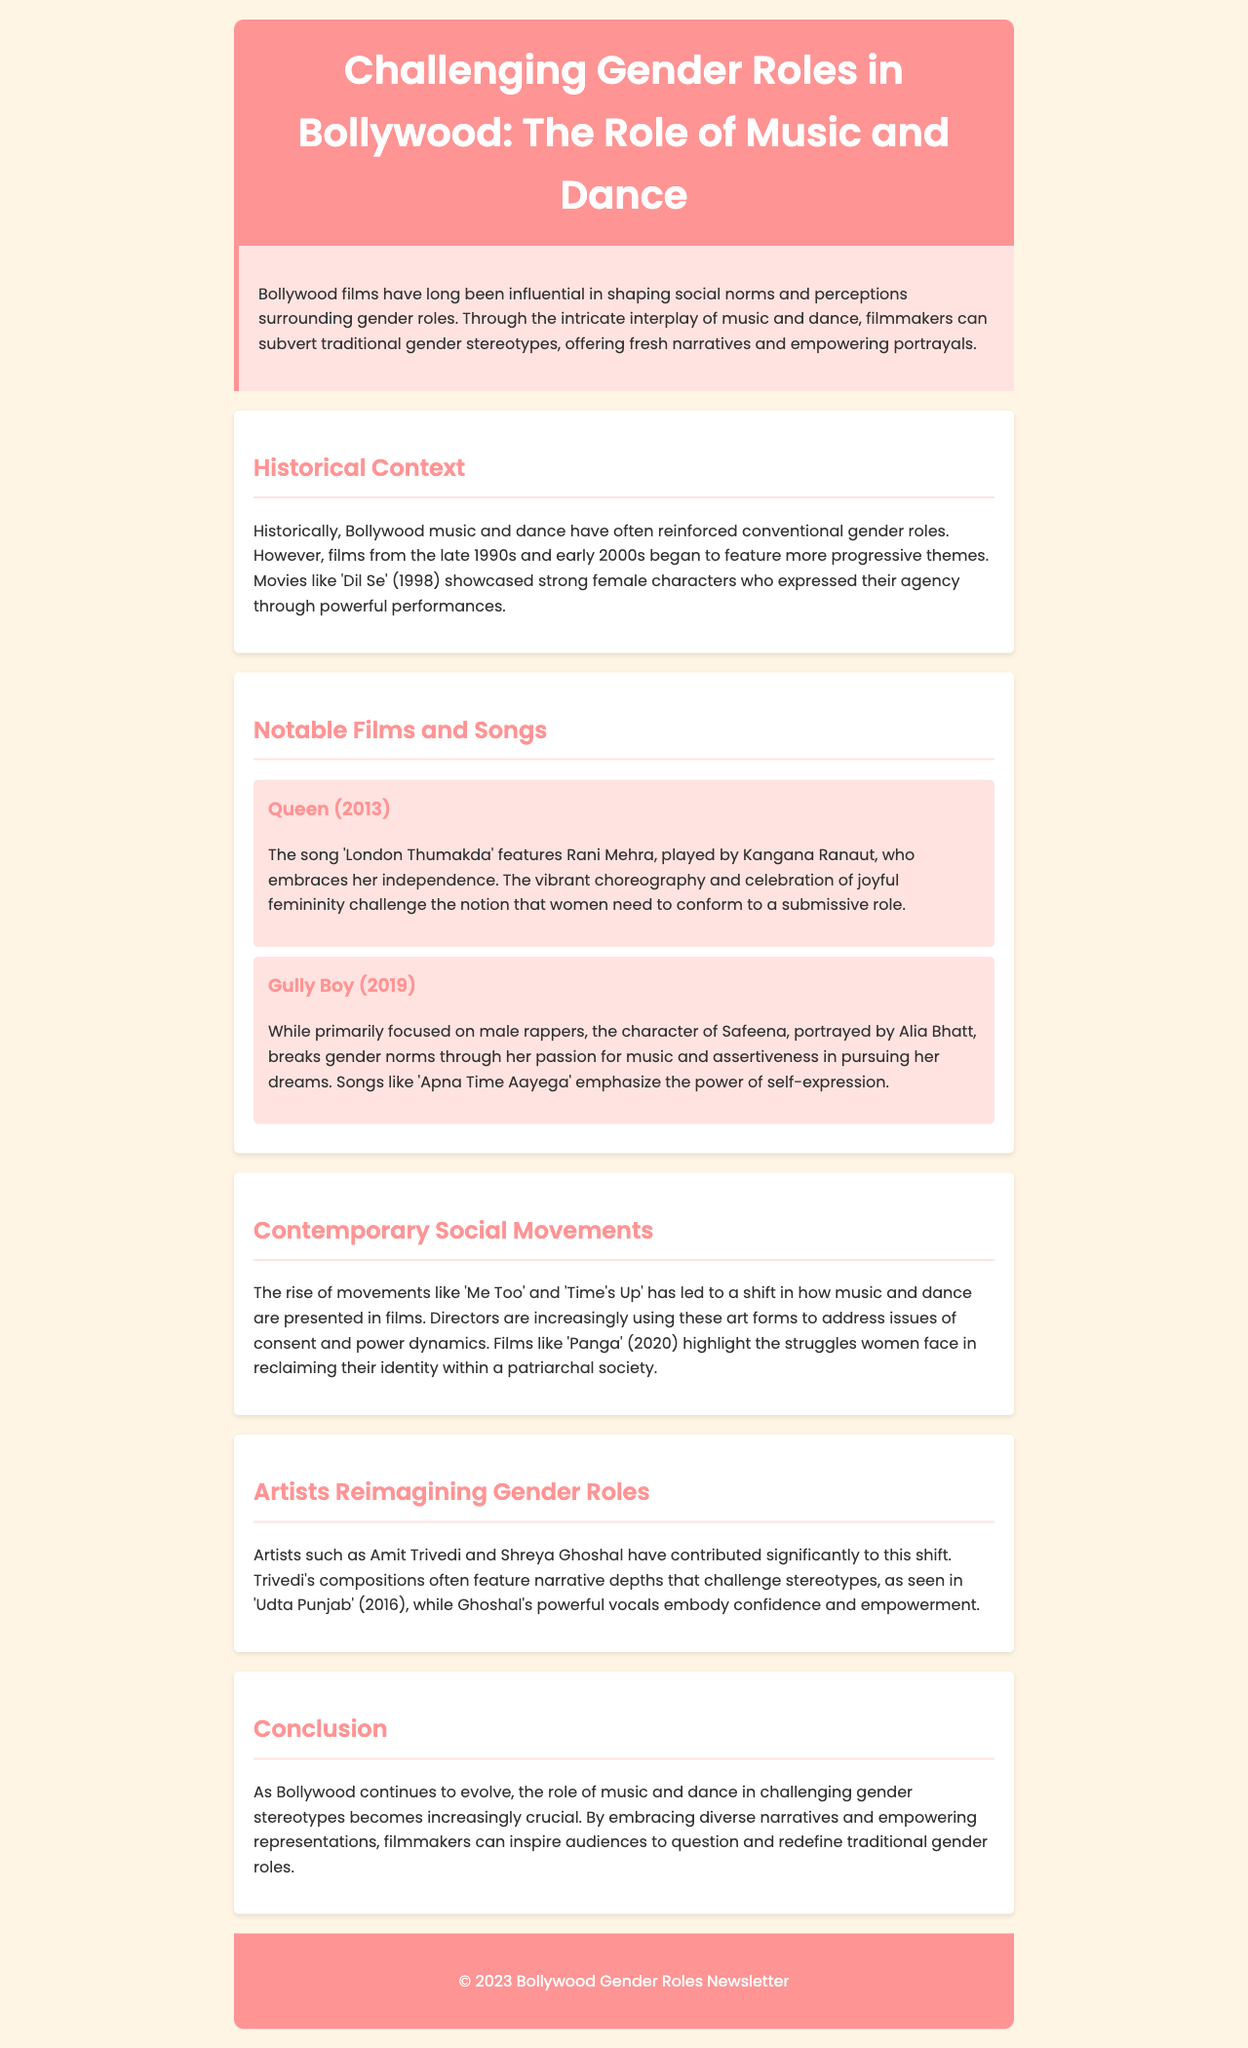What is the title of the newsletter? The title of the newsletter is presented in the header section, which is "Challenging Gender Roles in Bollywood: The Role of Music and Dance."
Answer: Challenging Gender Roles in Bollywood: The Role of Music and Dance Which film features the song 'London Thumakda'? The document mentions that the song 'London Thumakda' is featured in the film "Queen."
Answer: Queen What year was the film 'Gully Boy' released? The document states that 'Gully Boy' was released in the year 2019.
Answer: 2019 Which character in 'Gully Boy' challenges gender norms? The document highlights the character of Safeena, portrayed by Alia Bhatt, as someone who challenges gender norms.
Answer: Safeena What movement has influenced the representation of music and dance in Bollywood films? The document refers to movements like 'Me Too' and 'Time's Up' that have influenced representation in films.
Answer: Me Too and Time's Up Who composed the music that often challenges stereotypes in Bollywood? The document mentions Amit Trivedi as an artist whose compositions challenge stereotypes.
Answer: Amit Trivedi In which film are the struggles of women in a patriarchal society highlighted? The document points out that the film 'Panga' addresses these struggles.
Answer: Panga What genre of film is discussed in relation to challenging gender roles? The newsletter discusses Bollywood films in relation to challenging gender roles.
Answer: Bollywood films How does music and dance affect gender stereotypes in Bollywood? The document emphasizes that music and dance play a crucial role in challenging gender stereotypes.
Answer: Crucial role 